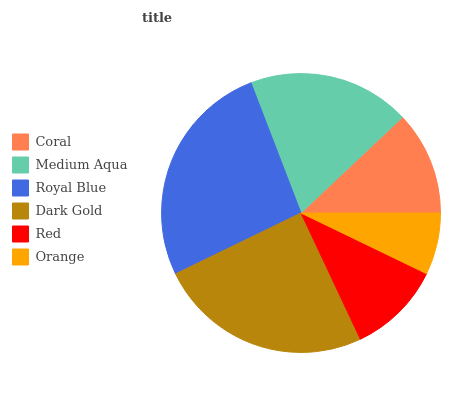Is Orange the minimum?
Answer yes or no. Yes. Is Royal Blue the maximum?
Answer yes or no. Yes. Is Medium Aqua the minimum?
Answer yes or no. No. Is Medium Aqua the maximum?
Answer yes or no. No. Is Medium Aqua greater than Coral?
Answer yes or no. Yes. Is Coral less than Medium Aqua?
Answer yes or no. Yes. Is Coral greater than Medium Aqua?
Answer yes or no. No. Is Medium Aqua less than Coral?
Answer yes or no. No. Is Medium Aqua the high median?
Answer yes or no. Yes. Is Coral the low median?
Answer yes or no. Yes. Is Red the high median?
Answer yes or no. No. Is Royal Blue the low median?
Answer yes or no. No. 